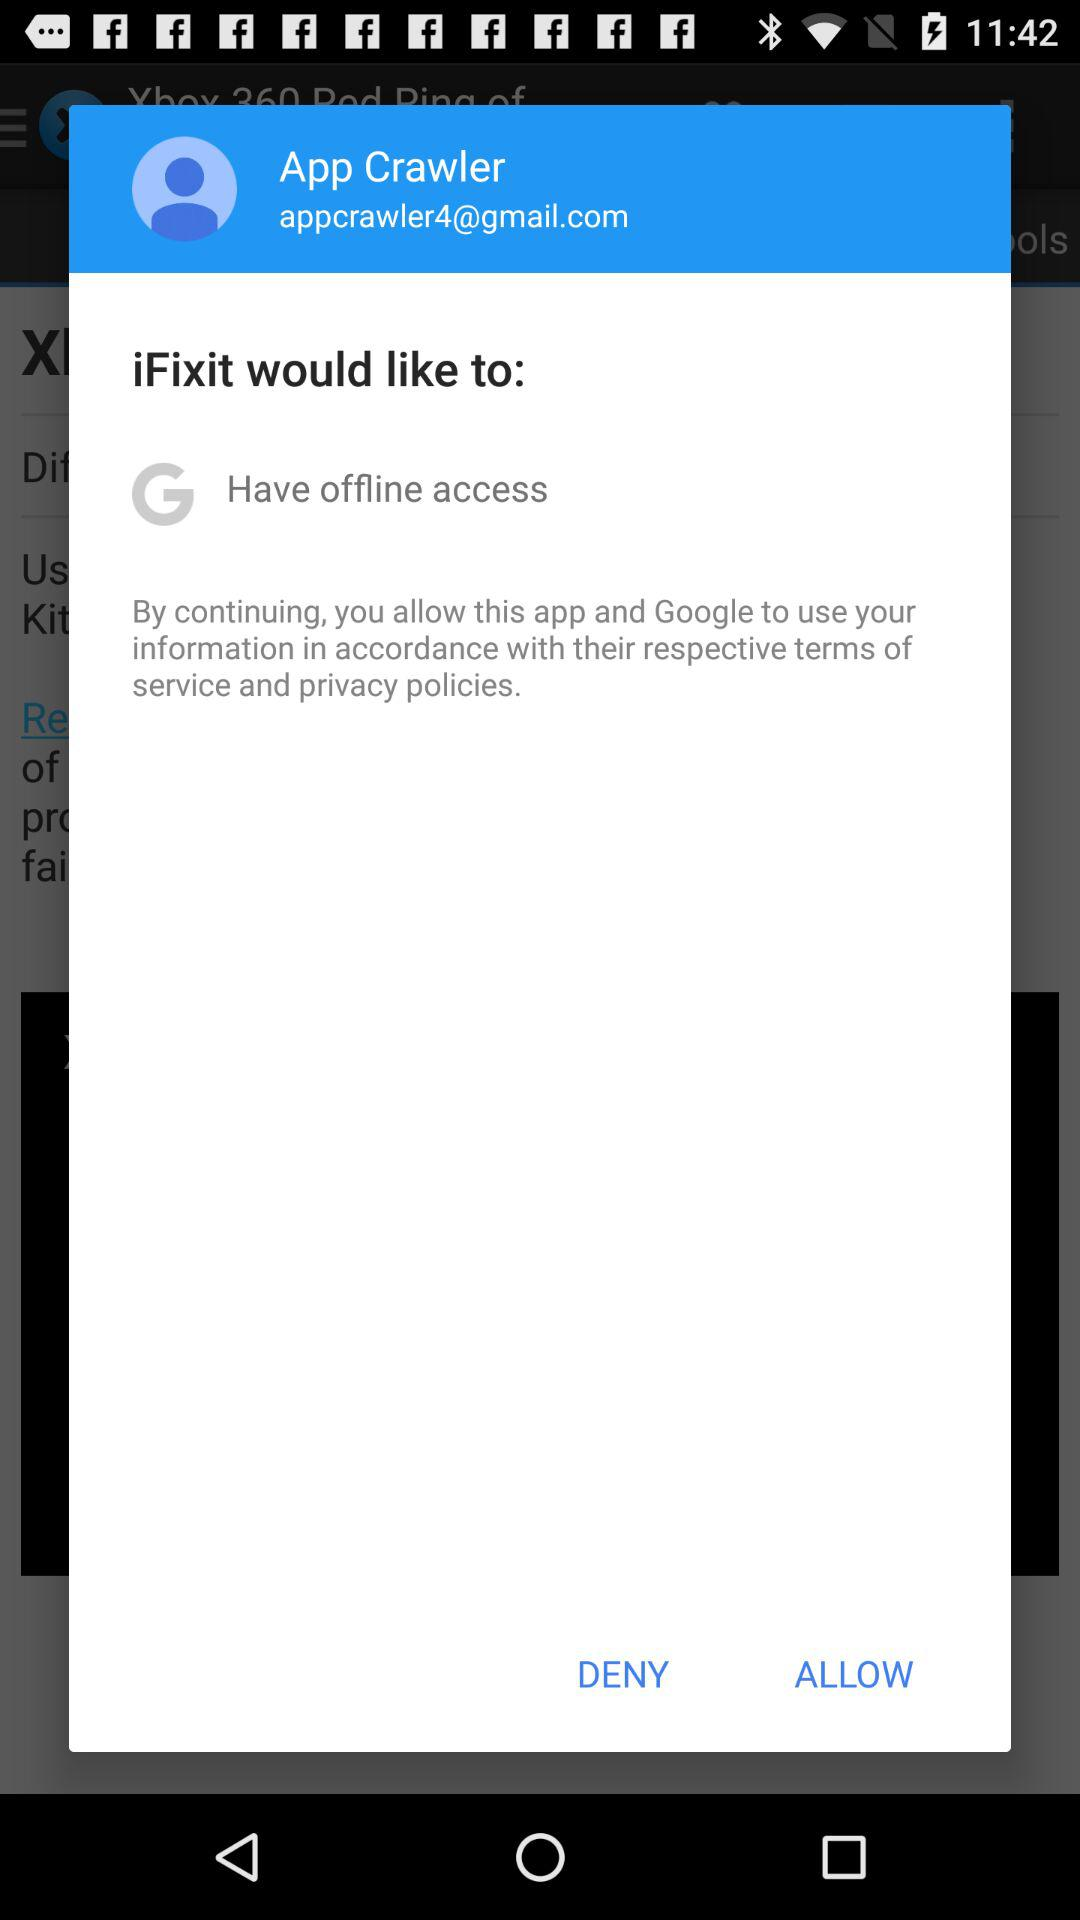Which applications are asking for access to the user information? The applications that are asking for access to the user information are "iFixit" and "Google". 